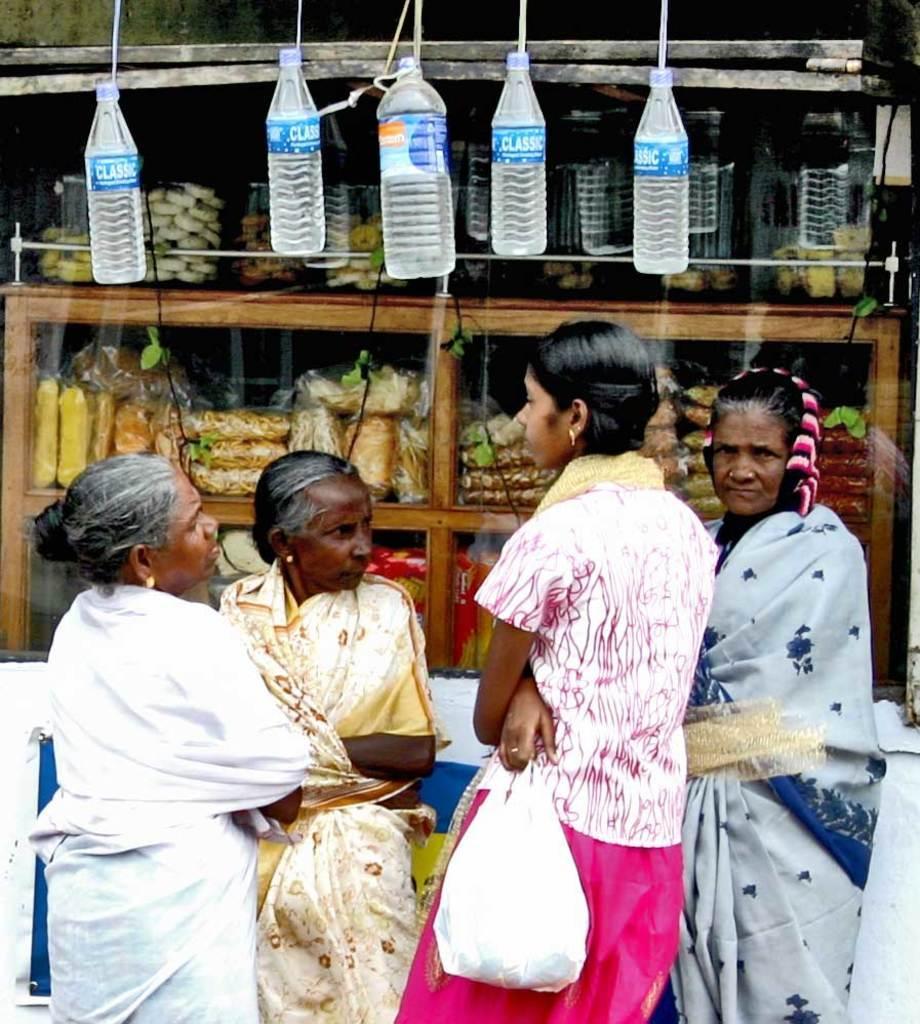Describe this image in one or two sentences. In this image i can see four women standing at the back ground i can see five bottles hanging and a food in a cupboard. 